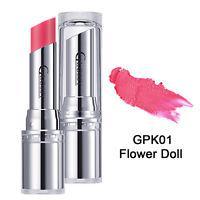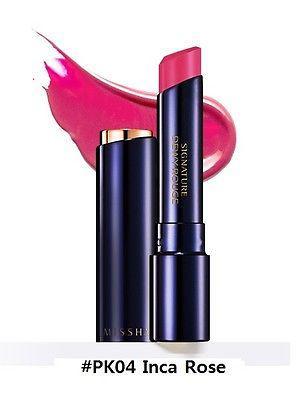The first image is the image on the left, the second image is the image on the right. For the images displayed, is the sentence "The lipstick in the right photo has a black case." factually correct? Answer yes or no. Yes. The first image is the image on the left, the second image is the image on the right. Assess this claim about the two images: "Each image shows just one lipstick next to its cap.". Correct or not? Answer yes or no. Yes. 